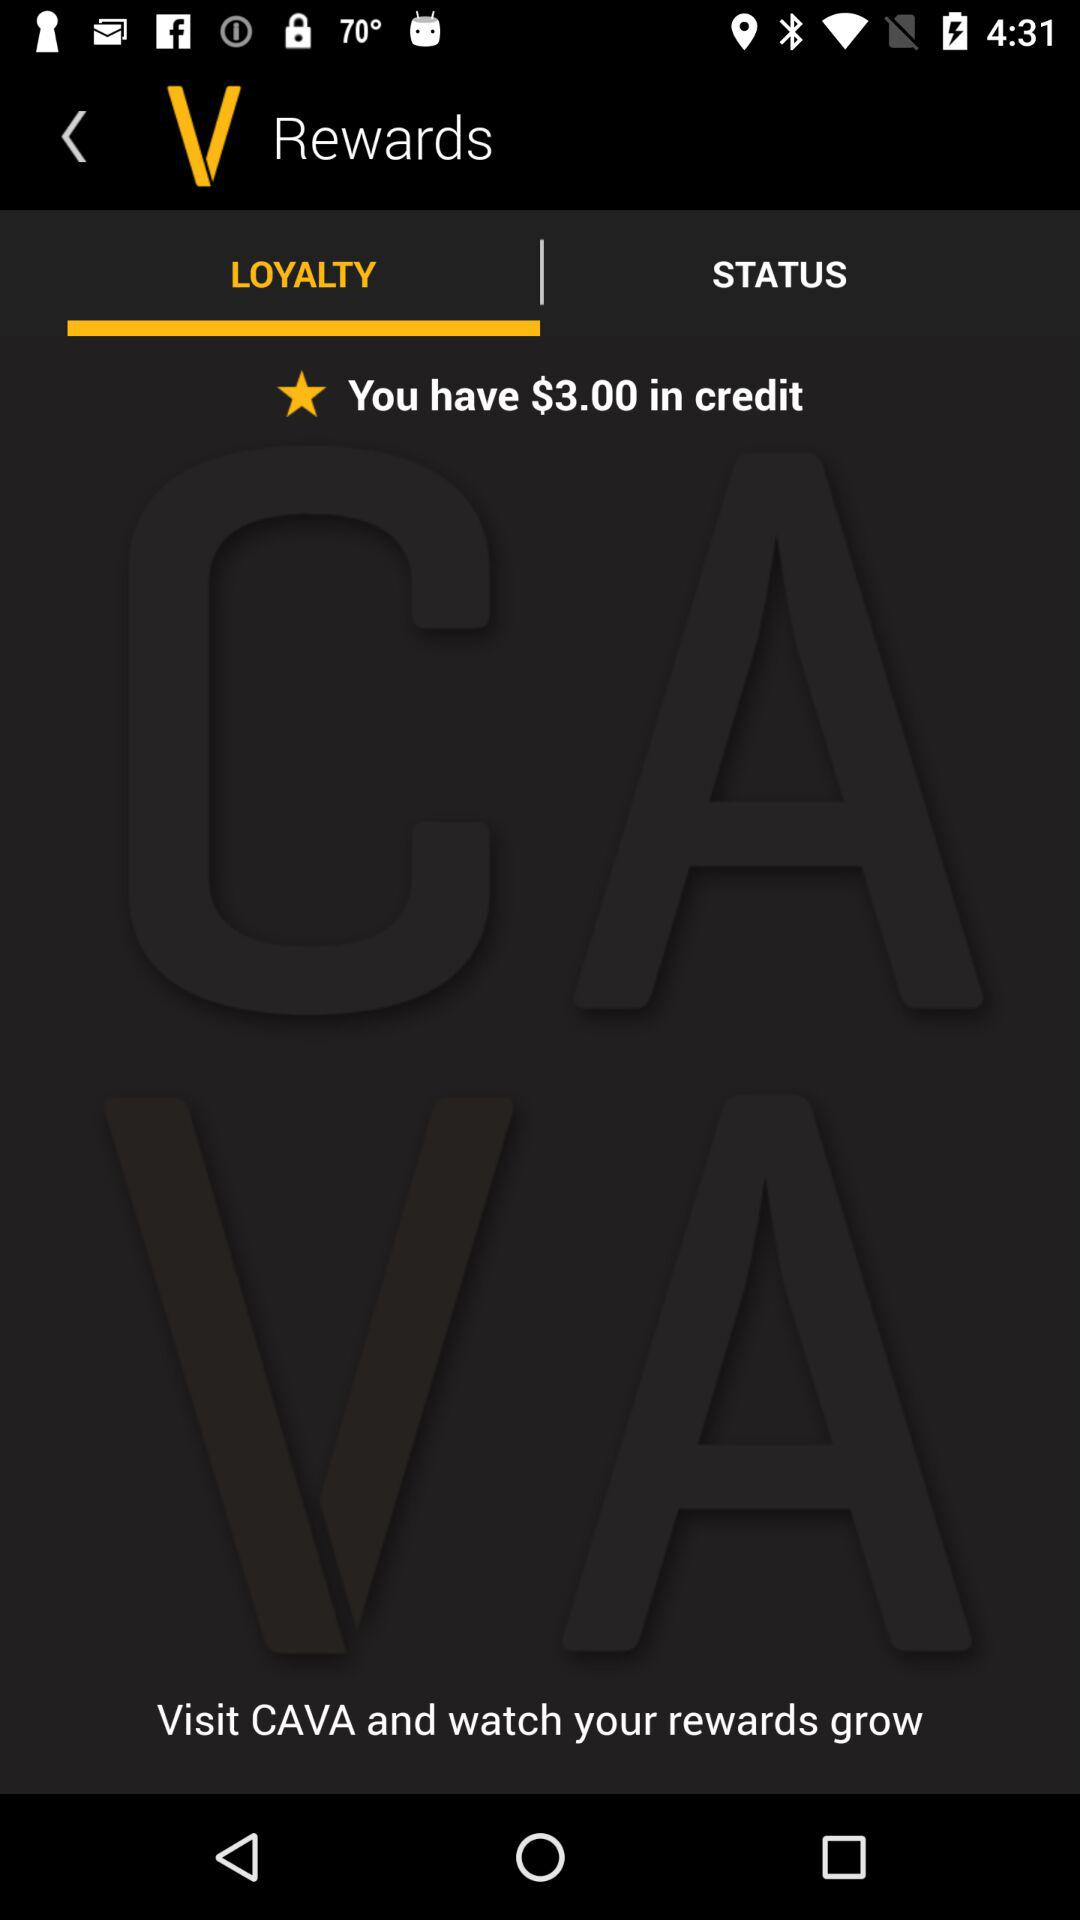How many dollars are in the credit? There are $3.00 in the credit. 